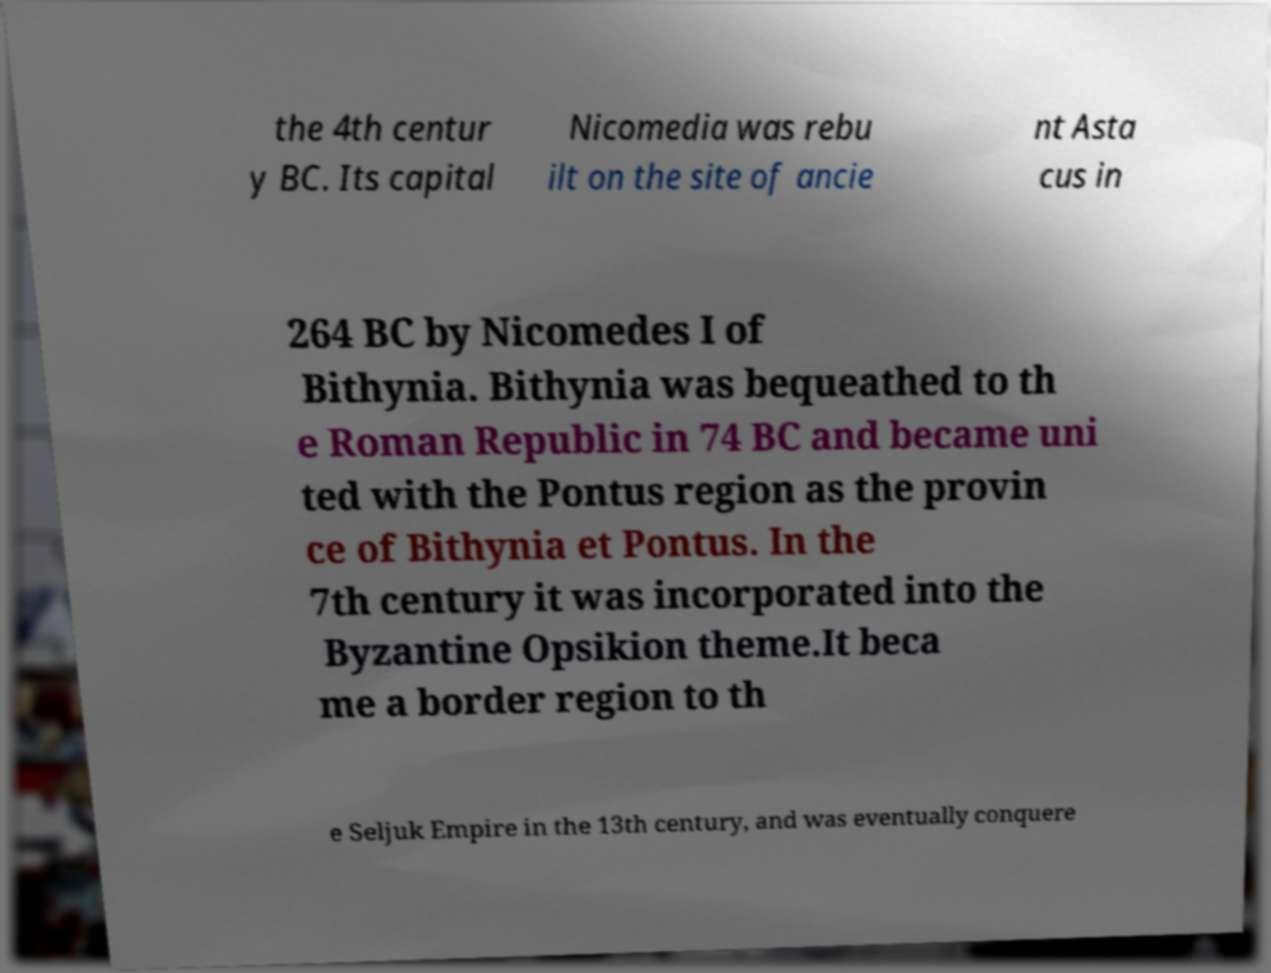Could you extract and type out the text from this image? the 4th centur y BC. Its capital Nicomedia was rebu ilt on the site of ancie nt Asta cus in 264 BC by Nicomedes I of Bithynia. Bithynia was bequeathed to th e Roman Republic in 74 BC and became uni ted with the Pontus region as the provin ce of Bithynia et Pontus. In the 7th century it was incorporated into the Byzantine Opsikion theme.It beca me a border region to th e Seljuk Empire in the 13th century, and was eventually conquere 